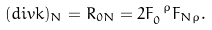Convert formula to latex. <formula><loc_0><loc_0><loc_500><loc_500>( d i v k ) _ { N } = R _ { 0 N } = 2 F _ { 0 } ^ { \ \rho } F _ { N \rho } .</formula> 